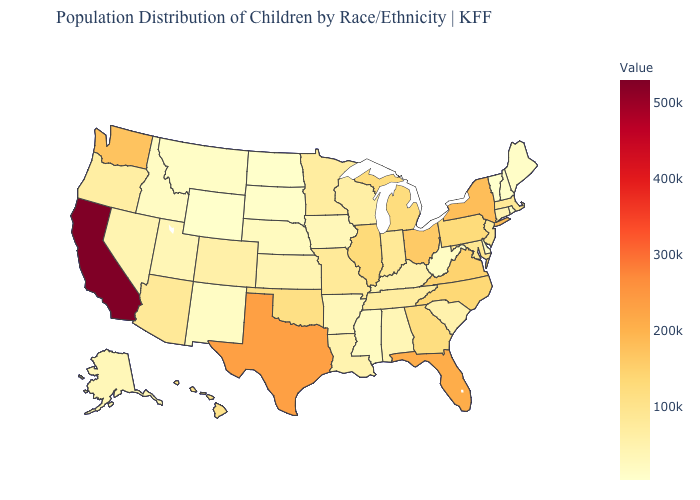Does Florida have the highest value in the USA?
Give a very brief answer. No. Which states have the lowest value in the Northeast?
Concise answer only. Vermont. Does North Dakota have the lowest value in the MidWest?
Quick response, please. Yes. Which states have the highest value in the USA?
Keep it brief. California. Among the states that border Massachusetts , which have the highest value?
Give a very brief answer. New York. Does Massachusetts have the lowest value in the USA?
Quick response, please. No. Among the states that border Kansas , which have the lowest value?
Concise answer only. Nebraska. 